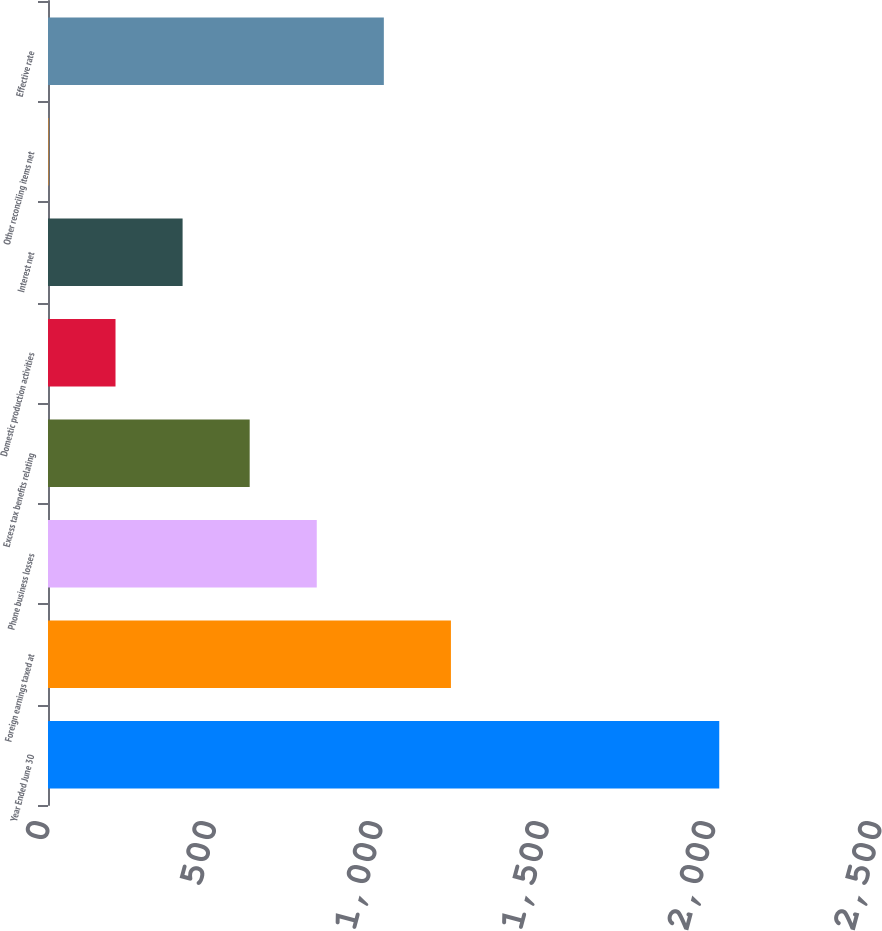<chart> <loc_0><loc_0><loc_500><loc_500><bar_chart><fcel>Year Ended June 30<fcel>Foreign earnings taxed at<fcel>Phone business losses<fcel>Excess tax benefits relating<fcel>Domestic production activities<fcel>Interest net<fcel>Other reconciling items net<fcel>Effective rate<nl><fcel>2017<fcel>1210.72<fcel>807.58<fcel>606.01<fcel>202.87<fcel>404.44<fcel>1.3<fcel>1009.15<nl></chart> 